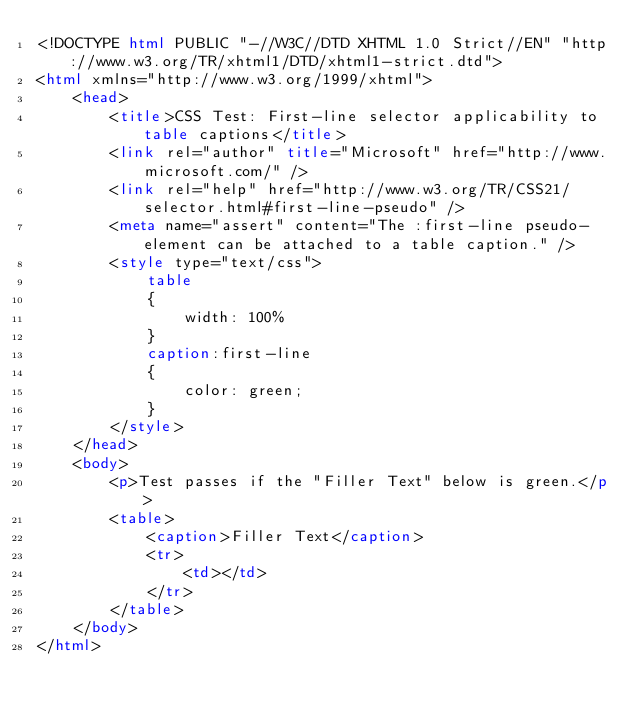<code> <loc_0><loc_0><loc_500><loc_500><_HTML_><!DOCTYPE html PUBLIC "-//W3C//DTD XHTML 1.0 Strict//EN" "http://www.w3.org/TR/xhtml1/DTD/xhtml1-strict.dtd">
<html xmlns="http://www.w3.org/1999/xhtml">
    <head>
        <title>CSS Test: First-line selector applicability to table captions</title>
        <link rel="author" title="Microsoft" href="http://www.microsoft.com/" />
        <link rel="help" href="http://www.w3.org/TR/CSS21/selector.html#first-line-pseudo" />
        <meta name="assert" content="The :first-line pseudo-element can be attached to a table caption." />
        <style type="text/css">
            table
            {
                width: 100%
            }
            caption:first-line
            {
                color: green;
            }
        </style>
    </head>
    <body>
        <p>Test passes if the "Filler Text" below is green.</p>
        <table>
            <caption>Filler Text</caption>
            <tr>
                <td></td>
            </tr>
        </table>
    </body>
</html></code> 